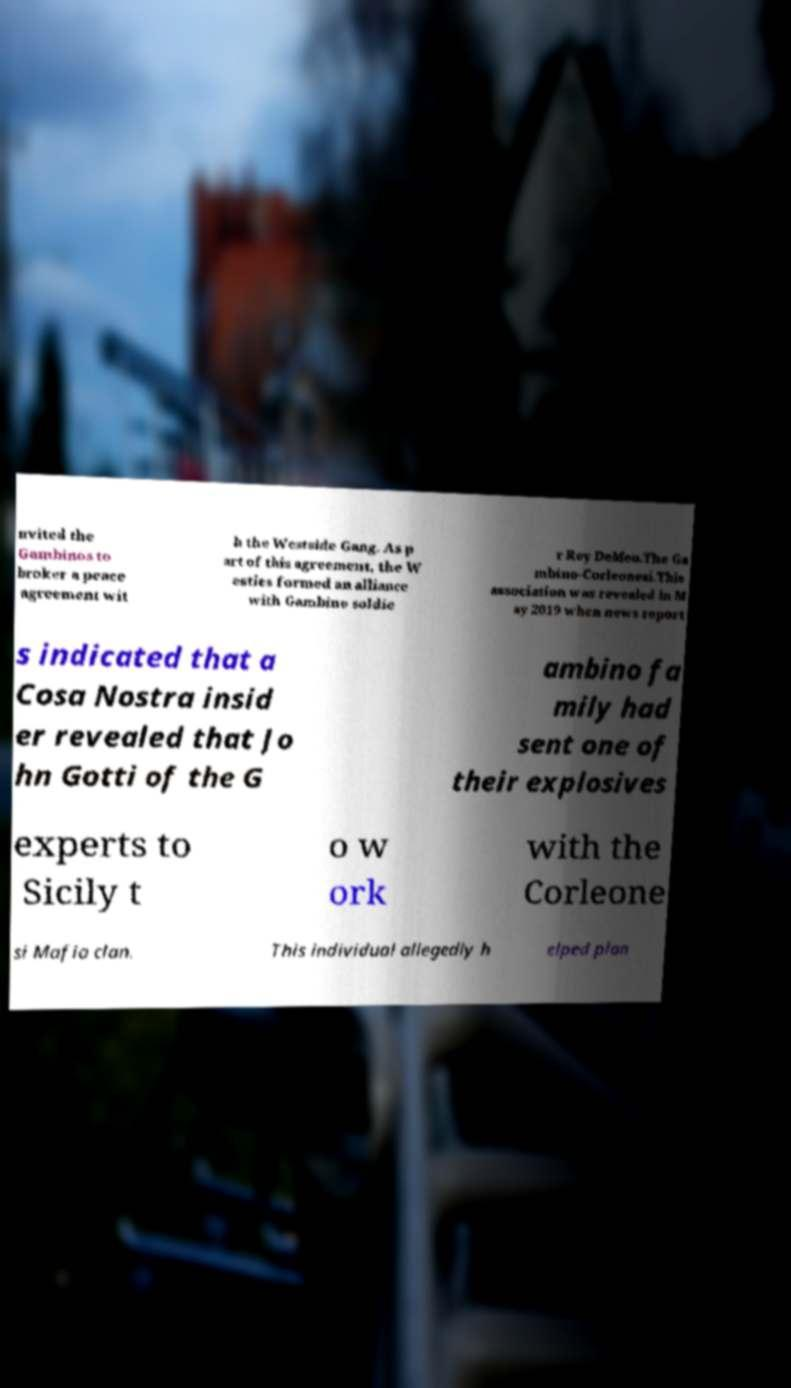Could you assist in decoding the text presented in this image and type it out clearly? nvited the Gambinos to broker a peace agreement wit h the Westside Gang. As p art of this agreement, the W esties formed an alliance with Gambino soldie r Roy DeMeo.The Ga mbino-Corleonesi.This association was revealed in M ay 2019 when news report s indicated that a Cosa Nostra insid er revealed that Jo hn Gotti of the G ambino fa mily had sent one of their explosives experts to Sicily t o w ork with the Corleone si Mafia clan. This individual allegedly h elped plan 